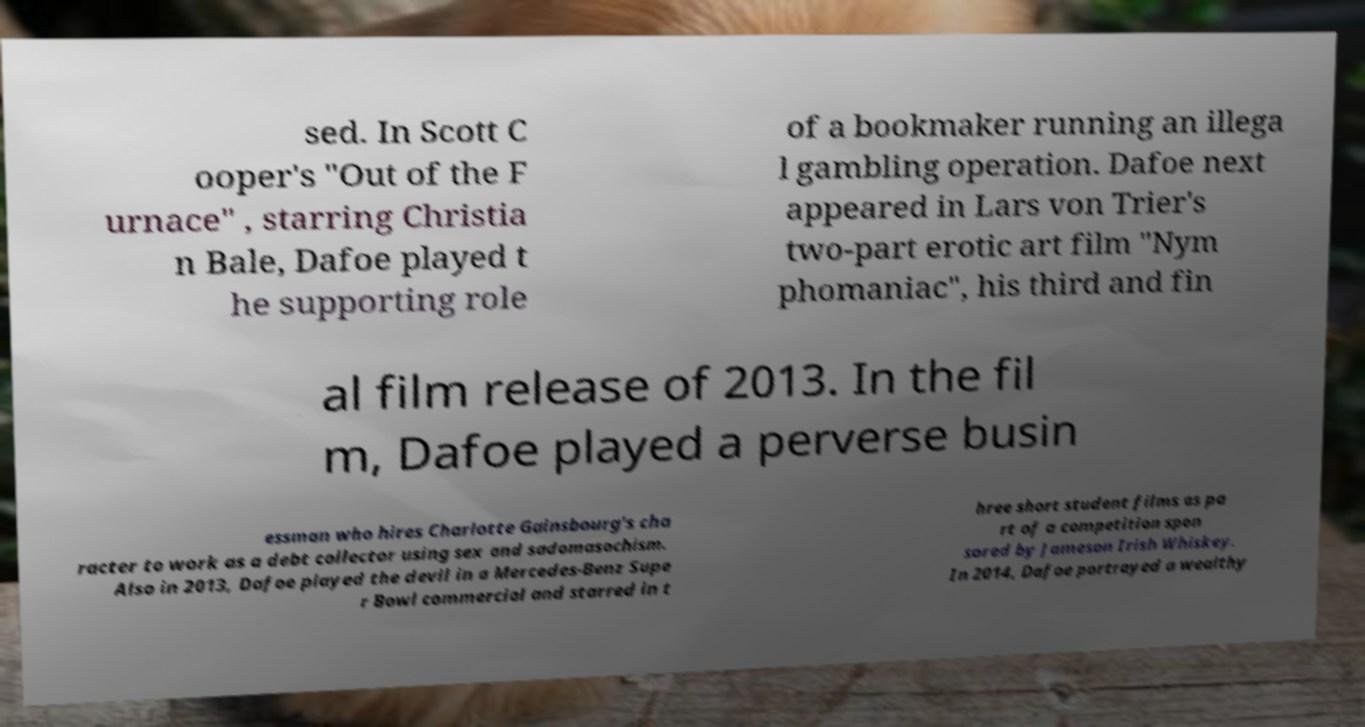Could you assist in decoding the text presented in this image and type it out clearly? sed. In Scott C ooper's "Out of the F urnace" , starring Christia n Bale, Dafoe played t he supporting role of a bookmaker running an illega l gambling operation. Dafoe next appeared in Lars von Trier's two-part erotic art film "Nym phomaniac", his third and fin al film release of 2013. In the fil m, Dafoe played a perverse busin essman who hires Charlotte Gainsbourg's cha racter to work as a debt collector using sex and sadomasochism. Also in 2013, Dafoe played the devil in a Mercedes-Benz Supe r Bowl commercial and starred in t hree short student films as pa rt of a competition spon sored by Jameson Irish Whiskey. In 2014, Dafoe portrayed a wealthy 